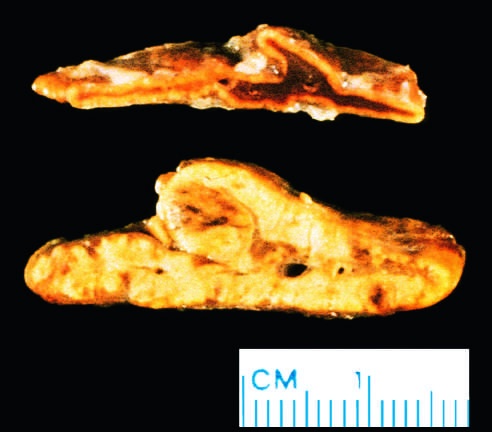how was the abnormal gland?
Answer the question using a single word or phrase. From a patient with acth-dependent cushing syndrome 